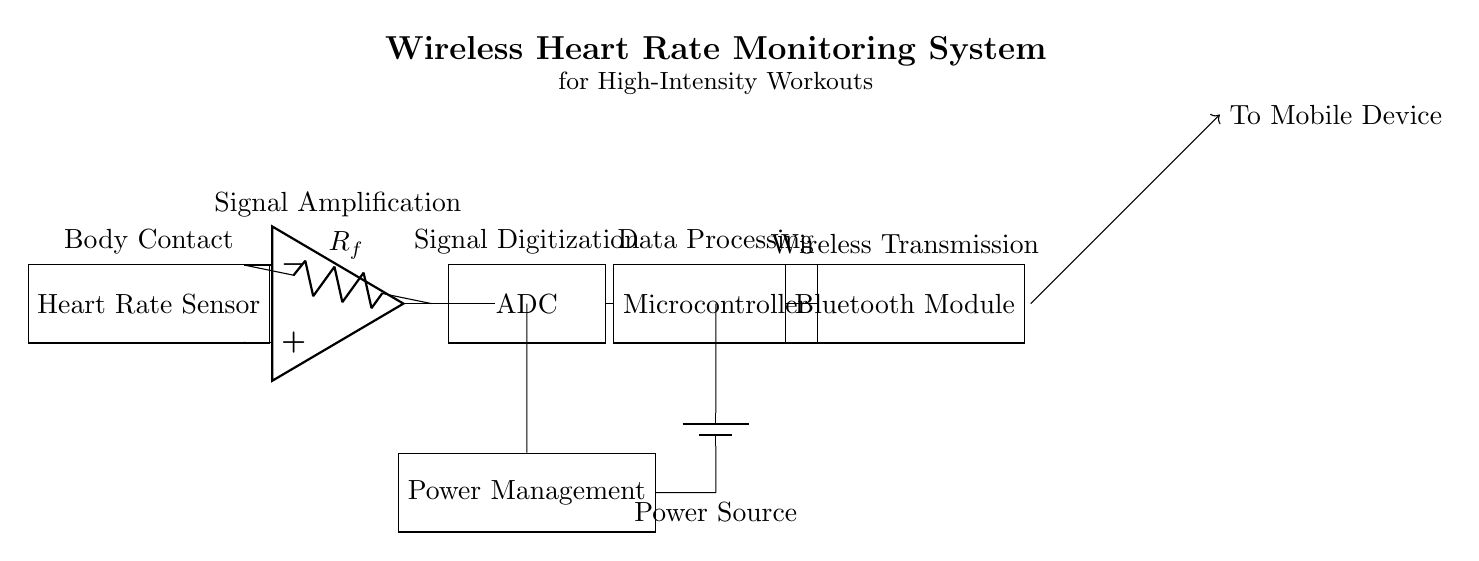What is the purpose of the heart rate sensor? The heart rate sensor is responsible for detecting the heart rate of the individual during the workout. It provides the initial signal that will be processed by the rest of the circuit.
Answer: Detecting heart rate What component is used for signal amplification? The operational amplifier, labeled as "op amp" in the diagram, is used to amplify the signal from the heart rate sensor, making it strong enough for further processing.
Answer: Operational amplifier What does the ADC stand for? The ADC, which stands for Analog to Digital Converter, converts the amplified analog signal from the heart rate sensor into a digital format for processing by the microcontroller.
Answer: Analog to Digital Converter Which component handles wireless transmission? The Bluetooth module is responsible for the wireless transmission of heart rate data to a mobile device, enabling real-time feedback.
Answer: Bluetooth Module What is the power source in this circuit? The power source in this circuit is a battery, which supplies the necessary voltage to operate all components within the system.
Answer: Battery How is the signal processed after digitization? After digitization, the digital signal is sent to the microcontroller, which processes the data and prepares it for transmission via Bluetooth.
Answer: Microcontroller What is the role of the power management component? The power management component regulates the power supply to ensure that all components receive the appropriate voltage and current for optimal operation, preventing damage or malfunction.
Answer: Regulates power supply 